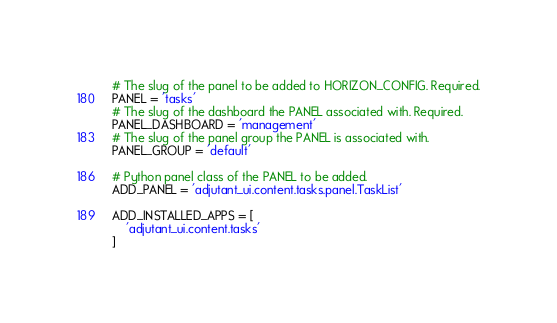<code> <loc_0><loc_0><loc_500><loc_500><_Python_># The slug of the panel to be added to HORIZON_CONFIG. Required.
PANEL = 'tasks'
# The slug of the dashboard the PANEL associated with. Required.
PANEL_DASHBOARD = 'management'
# The slug of the panel group the PANEL is associated with.
PANEL_GROUP = 'default'

# Python panel class of the PANEL to be added.
ADD_PANEL = 'adjutant_ui.content.tasks.panel.TaskList'

ADD_INSTALLED_APPS = [
    'adjutant_ui.content.tasks'
]
</code> 